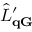Convert formula to latex. <formula><loc_0><loc_0><loc_500><loc_500>\hat { L } _ { q G } ^ { \prime }</formula> 